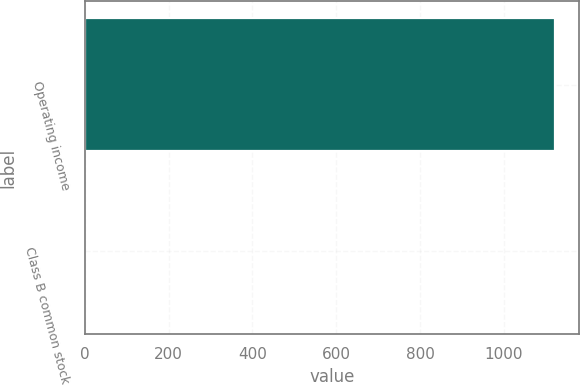<chart> <loc_0><loc_0><loc_500><loc_500><bar_chart><fcel>Operating income<fcel>Class B common stock<nl><fcel>1122<fcel>0.56<nl></chart> 